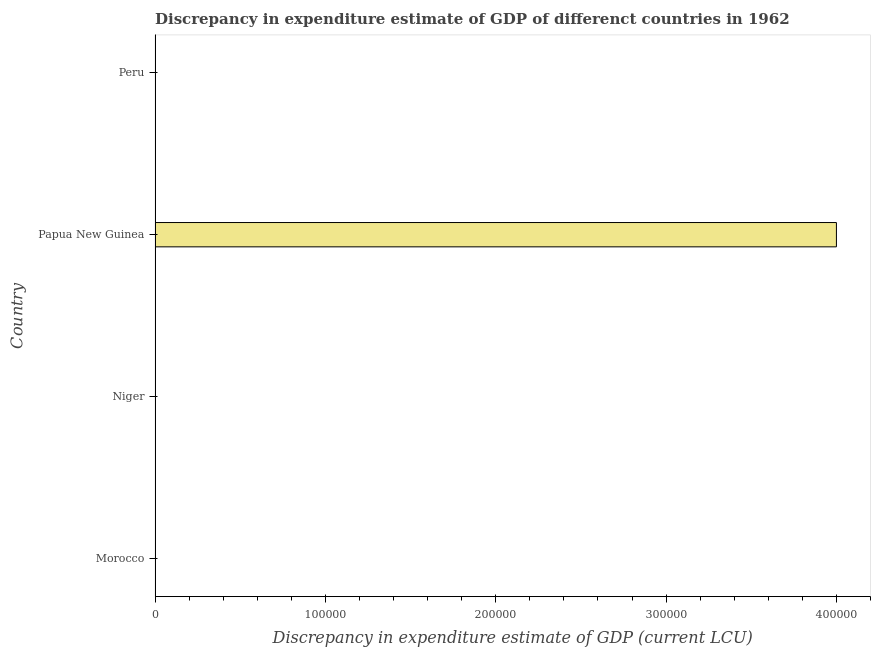What is the title of the graph?
Provide a succinct answer. Discrepancy in expenditure estimate of GDP of differenct countries in 1962. What is the label or title of the X-axis?
Your response must be concise. Discrepancy in expenditure estimate of GDP (current LCU). Across all countries, what is the minimum discrepancy in expenditure estimate of gdp?
Provide a short and direct response. 0. In which country was the discrepancy in expenditure estimate of gdp maximum?
Your answer should be compact. Papua New Guinea. What is the sum of the discrepancy in expenditure estimate of gdp?
Give a very brief answer. 4.00e+05. What is the average discrepancy in expenditure estimate of gdp per country?
Provide a short and direct response. 1.00e+05. What is the median discrepancy in expenditure estimate of gdp?
Keep it short and to the point. 0. In how many countries, is the discrepancy in expenditure estimate of gdp greater than 80000 LCU?
Give a very brief answer. 1. What is the difference between the highest and the lowest discrepancy in expenditure estimate of gdp?
Keep it short and to the point. 4.00e+05. How many bars are there?
Offer a very short reply. 1. How many countries are there in the graph?
Your answer should be very brief. 4. What is the Discrepancy in expenditure estimate of GDP (current LCU) in Niger?
Offer a terse response. 0. What is the Discrepancy in expenditure estimate of GDP (current LCU) of Papua New Guinea?
Provide a succinct answer. 4.00e+05. What is the Discrepancy in expenditure estimate of GDP (current LCU) of Peru?
Your response must be concise. 0. 